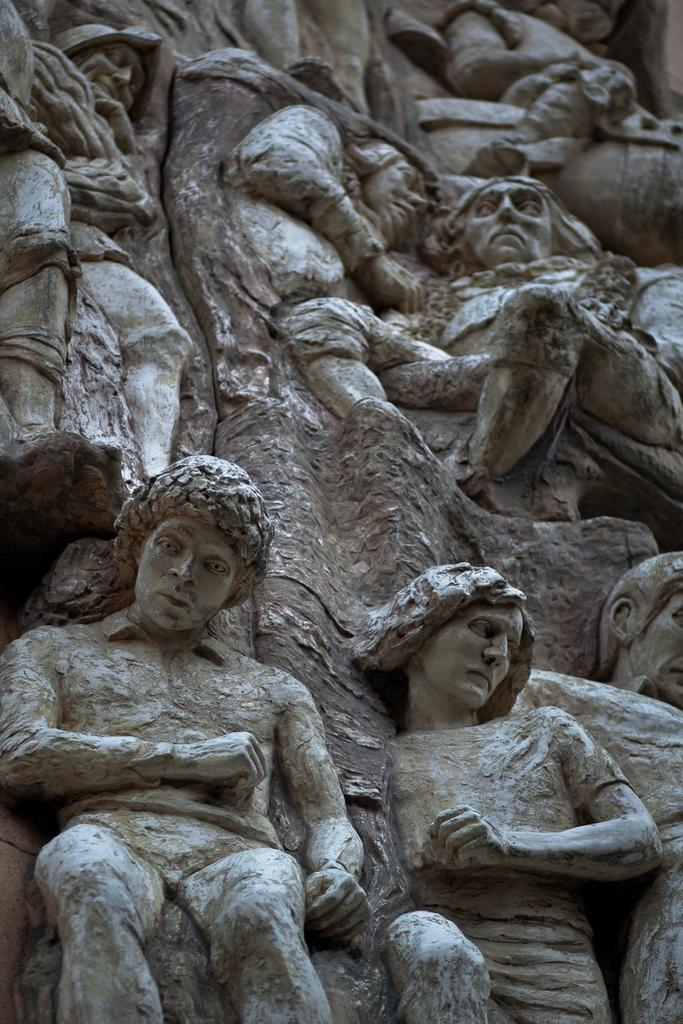What type of objects are in the image? There are people statues in the image. What color are the people statues? The people statues are in grey color. Where can the people statues be found providing support in the image? There is no indication in the image that the people statues are providing support. What type of food is being served in the lunchroom in the image? There is no lunchroom present in the image. What scientific experiment is being conducted in the image? There is no scientific experiment being conducted in the image. 